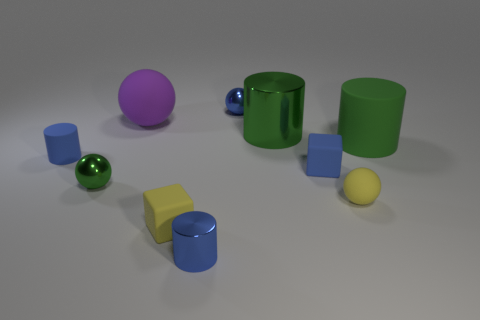What number of small blue metallic cubes are there?
Offer a very short reply. 0. How many green metal things are the same shape as the purple object?
Your response must be concise. 1. Does the big purple object have the same shape as the big green metal thing?
Make the answer very short. No. What is the size of the purple sphere?
Make the answer very short. Large. What number of yellow balls are the same size as the green matte cylinder?
Provide a short and direct response. 0. There is a metallic cylinder that is behind the big green matte thing; is its size the same as the cylinder that is left of the small yellow block?
Your answer should be very brief. No. There is a large matte object in front of the big purple sphere; what is its shape?
Your answer should be very brief. Cylinder. There is a tiny cylinder behind the blue cylinder that is to the right of the big ball; what is its material?
Ensure brevity in your answer.  Rubber. Are there any tiny matte spheres of the same color as the tiny metallic cylinder?
Your response must be concise. No. There is a purple ball; is its size the same as the block that is behind the tiny yellow rubber ball?
Your answer should be compact. No. 